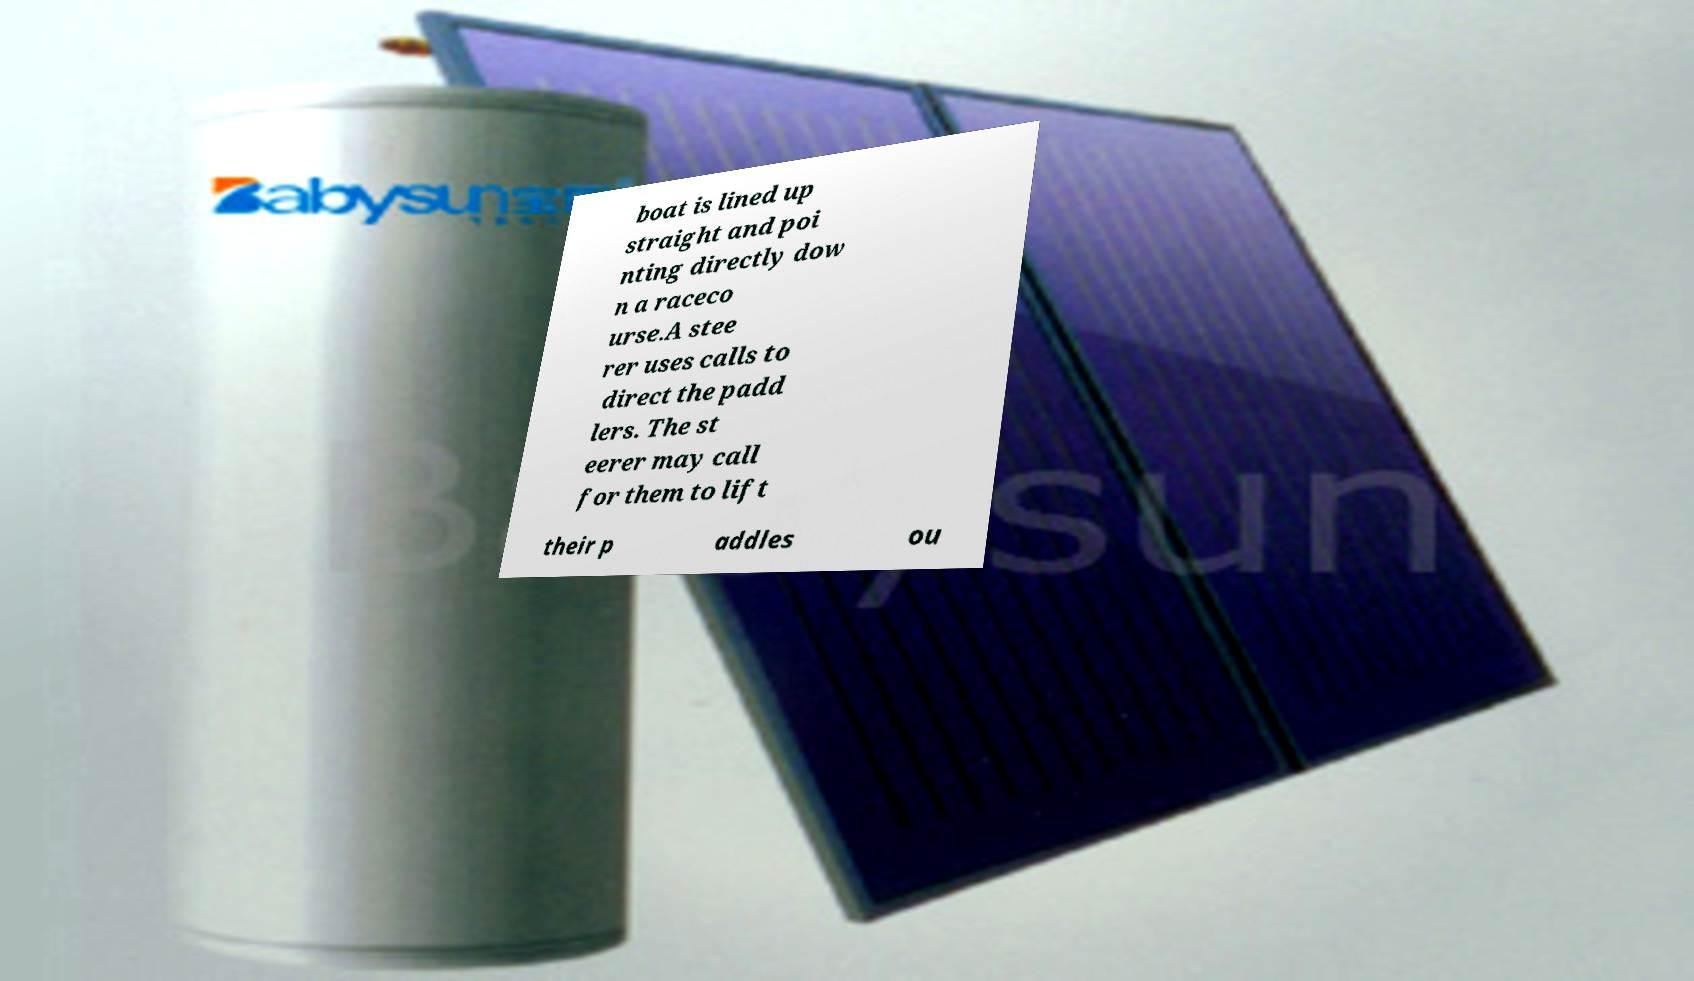For documentation purposes, I need the text within this image transcribed. Could you provide that? boat is lined up straight and poi nting directly dow n a raceco urse.A stee rer uses calls to direct the padd lers. The st eerer may call for them to lift their p addles ou 